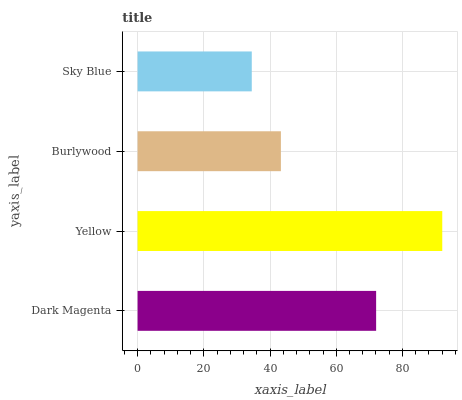Is Sky Blue the minimum?
Answer yes or no. Yes. Is Yellow the maximum?
Answer yes or no. Yes. Is Burlywood the minimum?
Answer yes or no. No. Is Burlywood the maximum?
Answer yes or no. No. Is Yellow greater than Burlywood?
Answer yes or no. Yes. Is Burlywood less than Yellow?
Answer yes or no. Yes. Is Burlywood greater than Yellow?
Answer yes or no. No. Is Yellow less than Burlywood?
Answer yes or no. No. Is Dark Magenta the high median?
Answer yes or no. Yes. Is Burlywood the low median?
Answer yes or no. Yes. Is Burlywood the high median?
Answer yes or no. No. Is Sky Blue the low median?
Answer yes or no. No. 